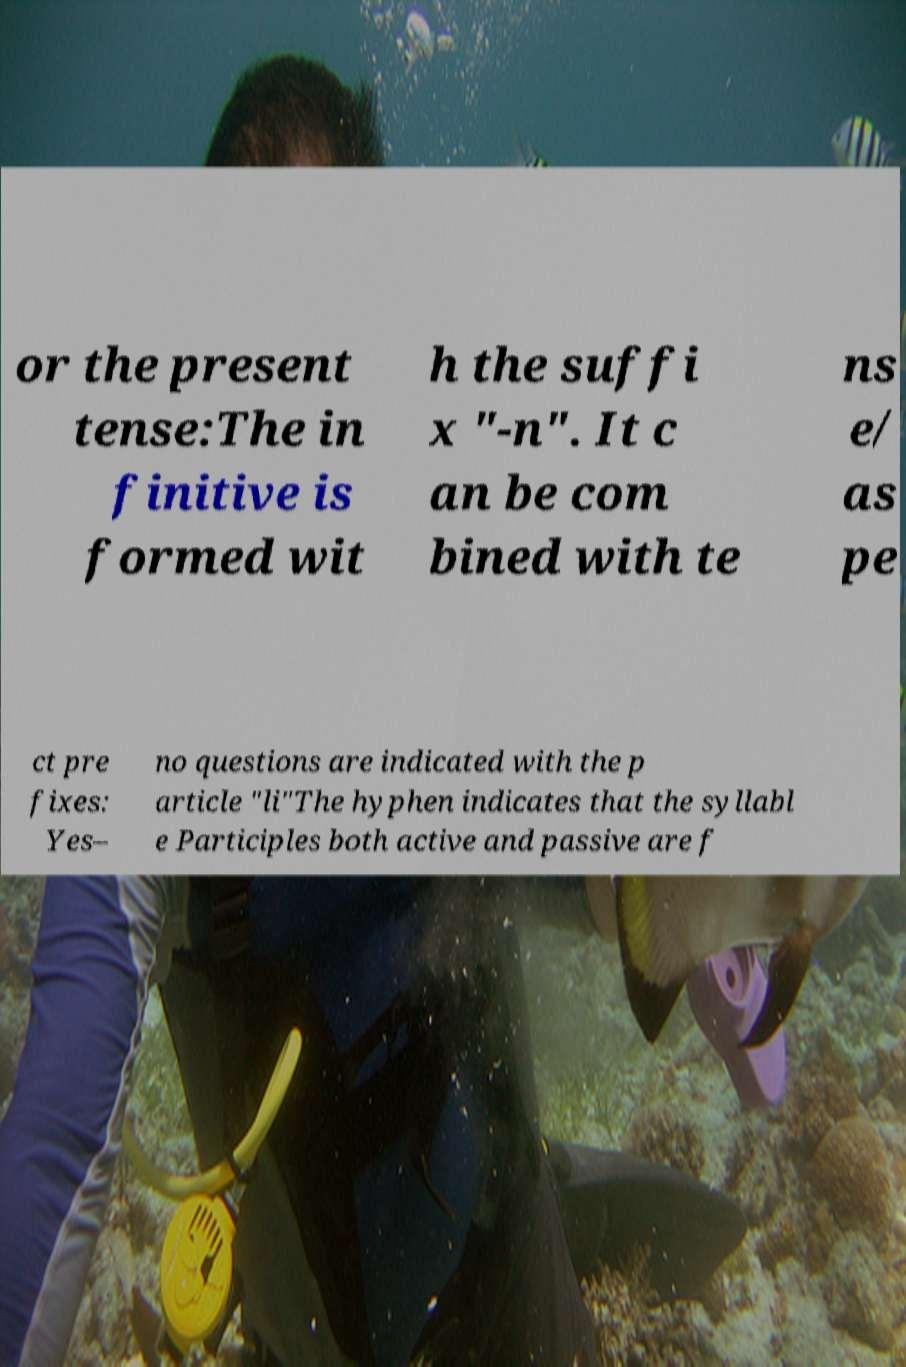There's text embedded in this image that I need extracted. Can you transcribe it verbatim? or the present tense:The in finitive is formed wit h the suffi x "-n". It c an be com bined with te ns e/ as pe ct pre fixes: Yes– no questions are indicated with the p article "li"The hyphen indicates that the syllabl e Participles both active and passive are f 